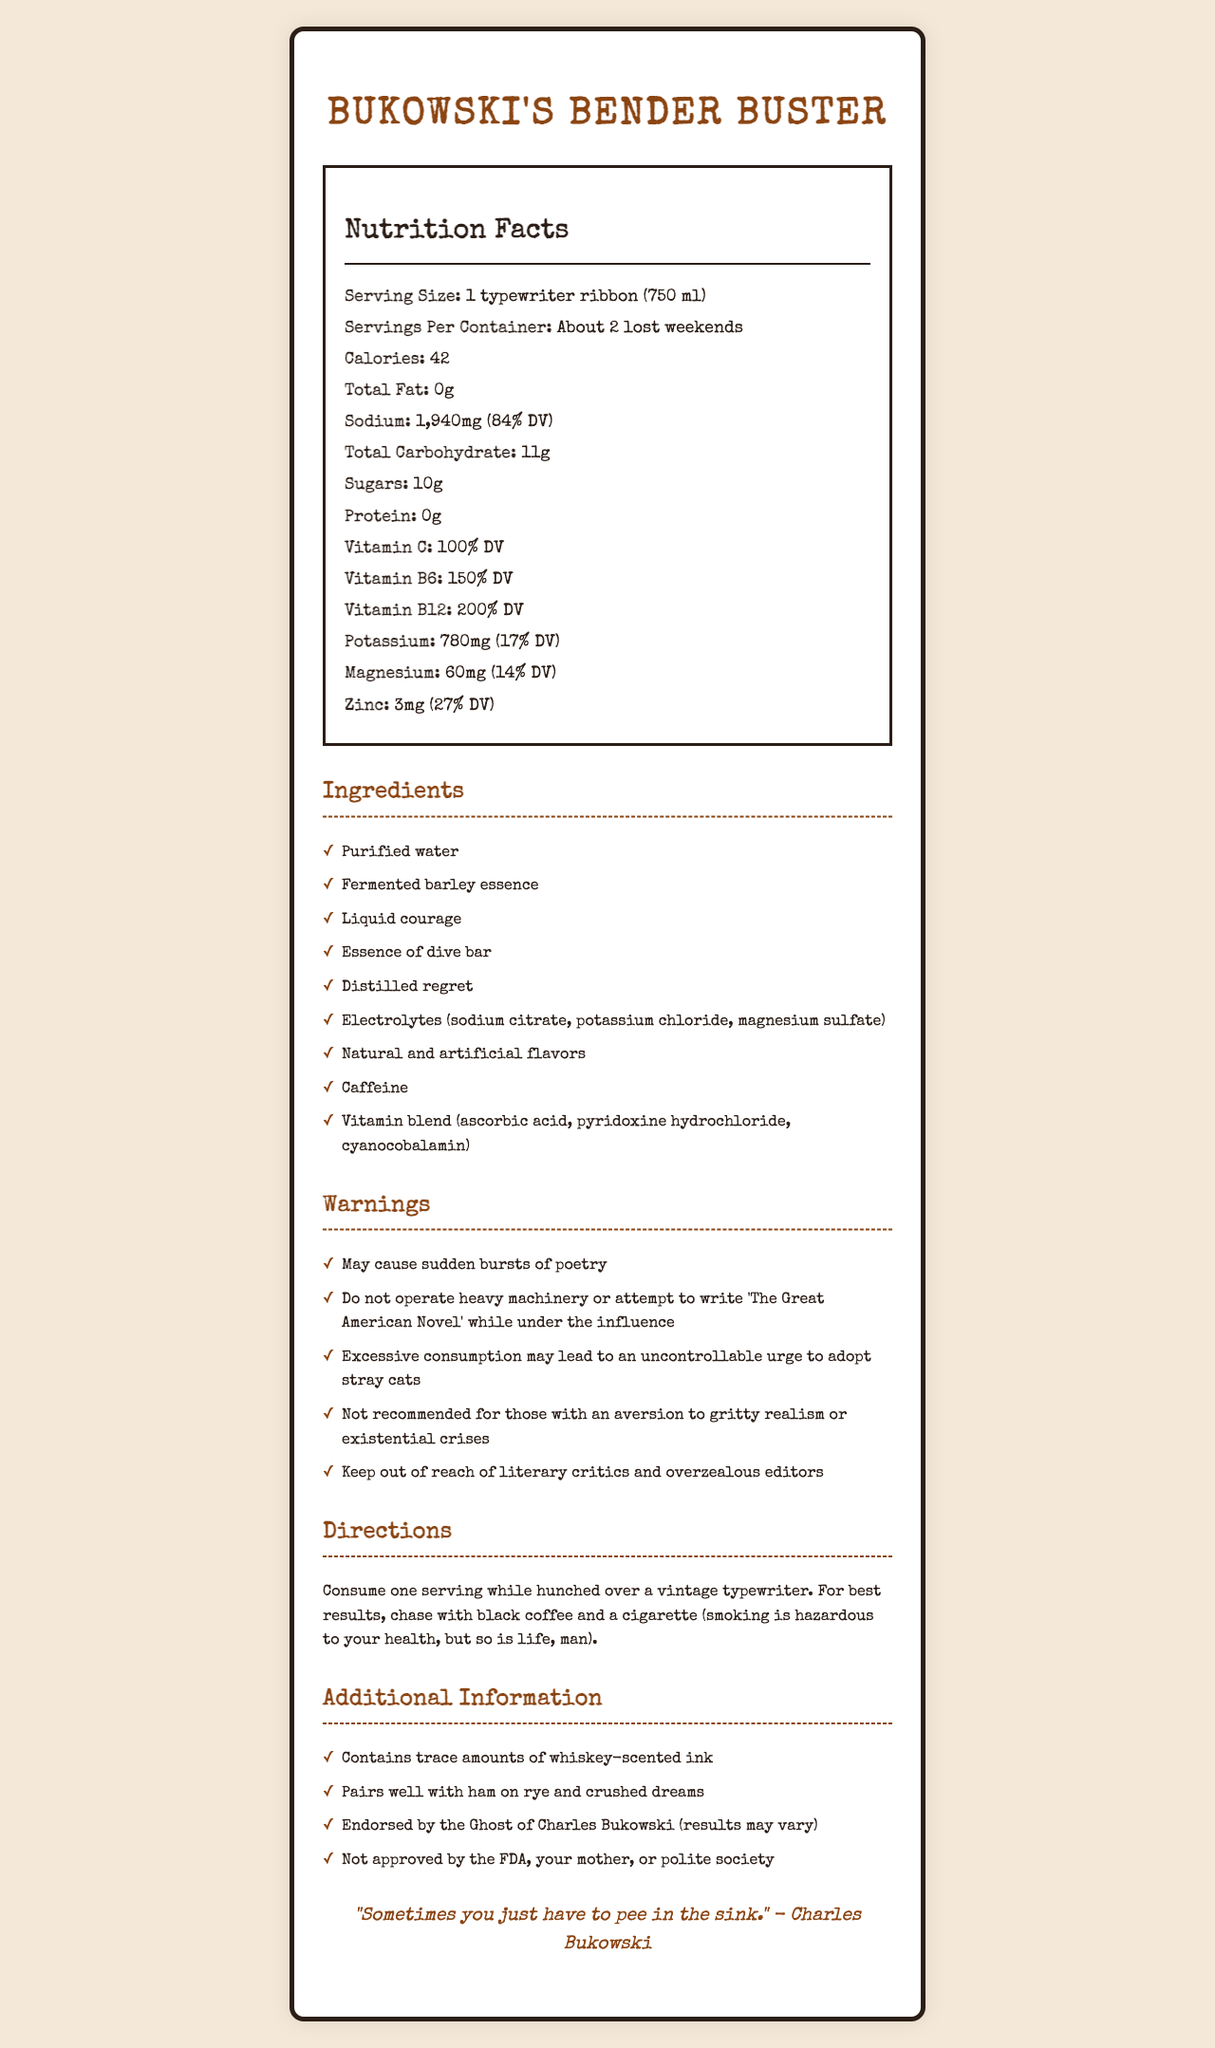what is the serving size of Bukowski's Bender Buster? The document lists the serving size as "1 typewriter ribbon (750 ml)".
Answer: 1 typewriter ribbon (750 ml) how many servings are there per container? The document states that there are "About 2 lost weekends" per container.
Answer: About 2 lost weekends how much sodium is in each serving of Bukowski's Bender Buster? The nutrition facts indicate that each serving contains 1,940mg of sodium, which is 84% of the daily value.
Answer: 1,940mg (84% DV) which vitamin is present in the highest daily value percentage? Vitamin B12 is present at 200% DV as per the nutrition facts listed.
Answer: Vitamin B12 what are the potential side effects mentioned in the warnings? These side effects are listed under the "Warnings" section of the document.
Answer: May cause sudden bursts of poetry, Do not operate heavy machinery or attempt to write 'The Great American Novel' while under the influence, Excessive consumption may lead to an uncontrollable urge to adopt stray cats, Not recommended for those with an aversion to gritty realism or existential crises, Keep out of reach of literary critics and overzealous editors what are the main ingredients of Bukowski's Bender Buster? The main ingredients are listed in the 'Ingredients' section.
Answer: Purified water, Fermented barley essence, Liquid courage, Essence of dive bar, Distilled regret, Electrolytes (sodium citrate, potassium chloride, magnesium sulfate), Natural and artificial flavors, Caffeine, Vitamin blend (ascorbic acid, pyridoxine hydrochloride, cyanocobalamin) what activities are warned against while consuming Bukowski's Bender Buster? A. Driving a car B. Operating heavy machinery C. Going on a hike D. Attempting to write "The Great American Novel" The warnings section advises against operating heavy machinery and attempting to write "The Great American Novel" while under the influence.
Answer: B, D which of the following nutritional components are zero in Bukowski's Bender Buster? I. Total Fat II. Sugars III. Protein IV. Total Carbohydrate The nutrition facts state that Total Fat (0g) and Protein (0g) are zero.
Answer: I, III can you consume Bukowski's Bender Buster without any side effects if you don't operate heavy machinery? The warnings suggest multiple side effects including sudden bursts of poetry, adopting stray cats, and risks for those averse to gritty realism.
Answer: No what is the recommended way to consume Bukowski's Bender Buster? The directions provide a specific method to consume the drink.
Answer: Consume one serving while hunched over a vintage typewriter. For best results, chase with black coffee and a cigarette (smoking is hazardous to your health, but so is life, man). how much potassium does Bukowski's Bender Buster contain per serving? The document lists the potassium content as 780mg per serving, which is 17% of the daily value.
Answer: 780mg (17% DV) summarize the overall information about Bukowski's Bender Buster provided in this document. The document summarizes the product information, nutritional content, ingredients, warnings, and humorously suggests ways to consume the drink in a Bukowski-inspired manner.
Answer: Bukowski's Bender Buster is an electrolyte drink with a humorous take, referencing Charles Bukowski. It has a unique serving size and exaggerated nutrition facts. It contains vitamins and minerals but also comes with whimsical warnings and side effects. The document humorously suggests the drink may cause literary tendencies and pairs well with certain Bukowski-inspired items. Directions for consumption also reflect Bukowski's lifestyle. why is the potassium content significant in Bukowski's Bender Buster? The document provides the potassium content but does not explain why it is significant or what specific benefits it provides.
Answer: Cannot be determined 